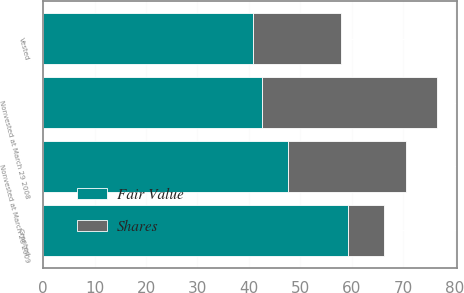Convert chart to OTSL. <chart><loc_0><loc_0><loc_500><loc_500><stacked_bar_chart><ecel><fcel>Nonvested at March 29 2008<fcel>Granted<fcel>Vested<fcel>Nonvested at March 28 2009<nl><fcel>Shares<fcel>34<fcel>7<fcel>17<fcel>23<nl><fcel>Fair Value<fcel>42.6<fcel>59.22<fcel>40.86<fcel>47.58<nl></chart> 